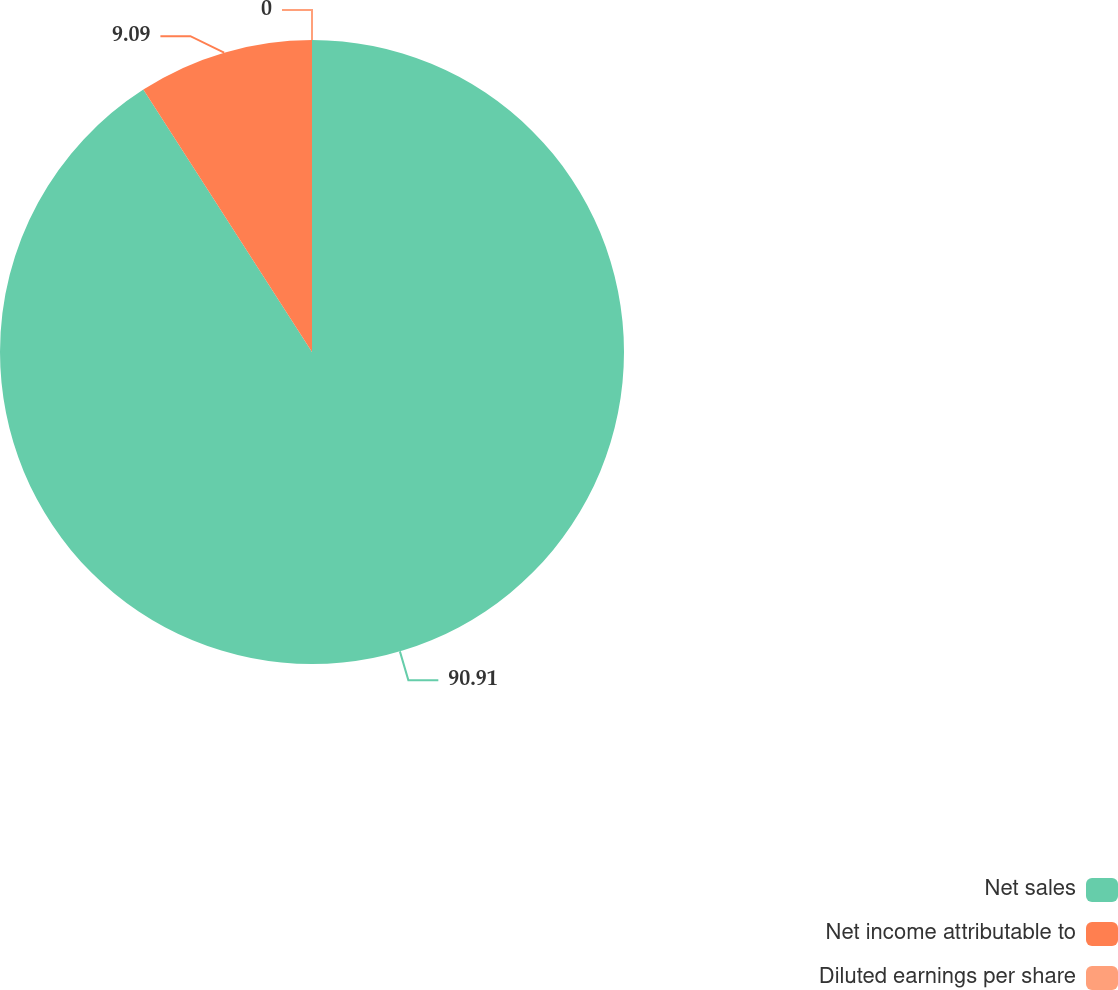Convert chart to OTSL. <chart><loc_0><loc_0><loc_500><loc_500><pie_chart><fcel>Net sales<fcel>Net income attributable to<fcel>Diluted earnings per share<nl><fcel>90.91%<fcel>9.09%<fcel>0.0%<nl></chart> 